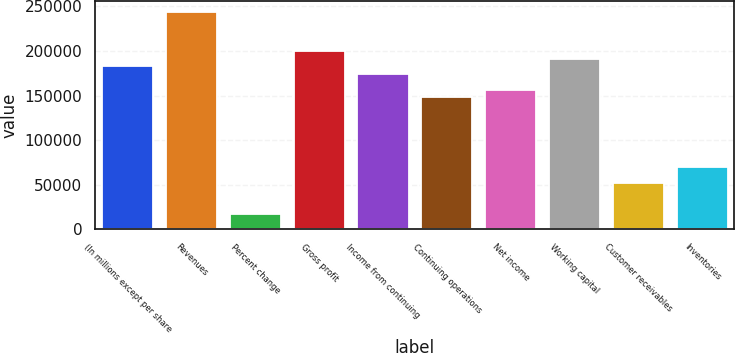<chart> <loc_0><loc_0><loc_500><loc_500><bar_chart><fcel>(In millions except per share<fcel>Revenues<fcel>Percent change<fcel>Gross profit<fcel>Income from continuing<fcel>Continuing operations<fcel>Net income<fcel>Working capital<fcel>Customer receivables<fcel>Inventories<nl><fcel>182664<fcel>243552<fcel>17396.8<fcel>200061<fcel>173966<fcel>147871<fcel>156569<fcel>191362<fcel>52189.9<fcel>69586.5<nl></chart> 